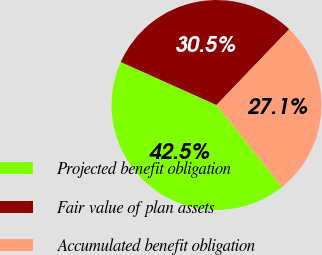Convert chart. <chart><loc_0><loc_0><loc_500><loc_500><pie_chart><fcel>Projected benefit obligation<fcel>Fair value of plan assets<fcel>Accumulated benefit obligation<nl><fcel>42.47%<fcel>30.45%<fcel>27.08%<nl></chart> 